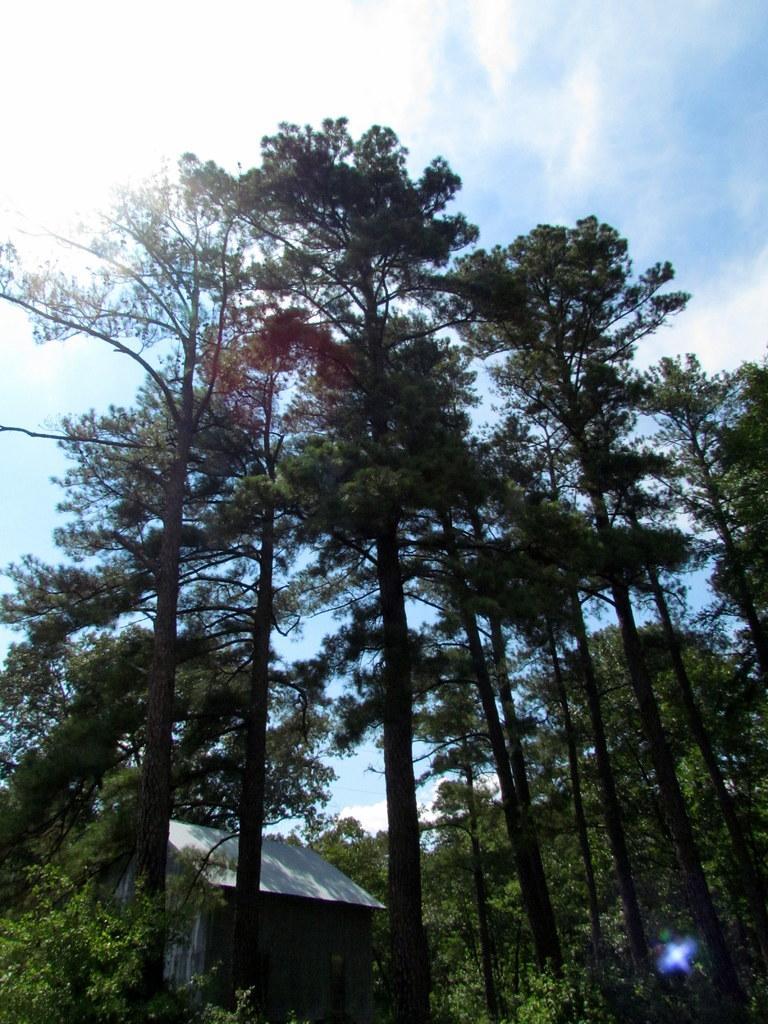In one or two sentences, can you explain what this image depicts? In this image there are many trees. Also there is a small building. In the background there is sky with clouds. 